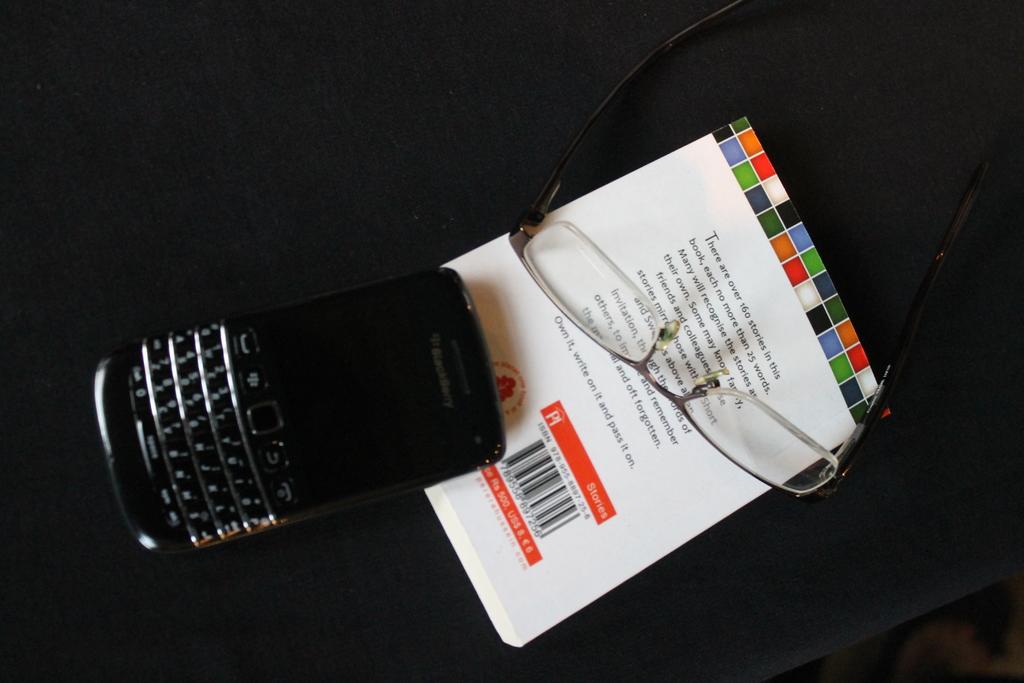What brand is the cellphone?
Your answer should be very brief. Blackberry. 